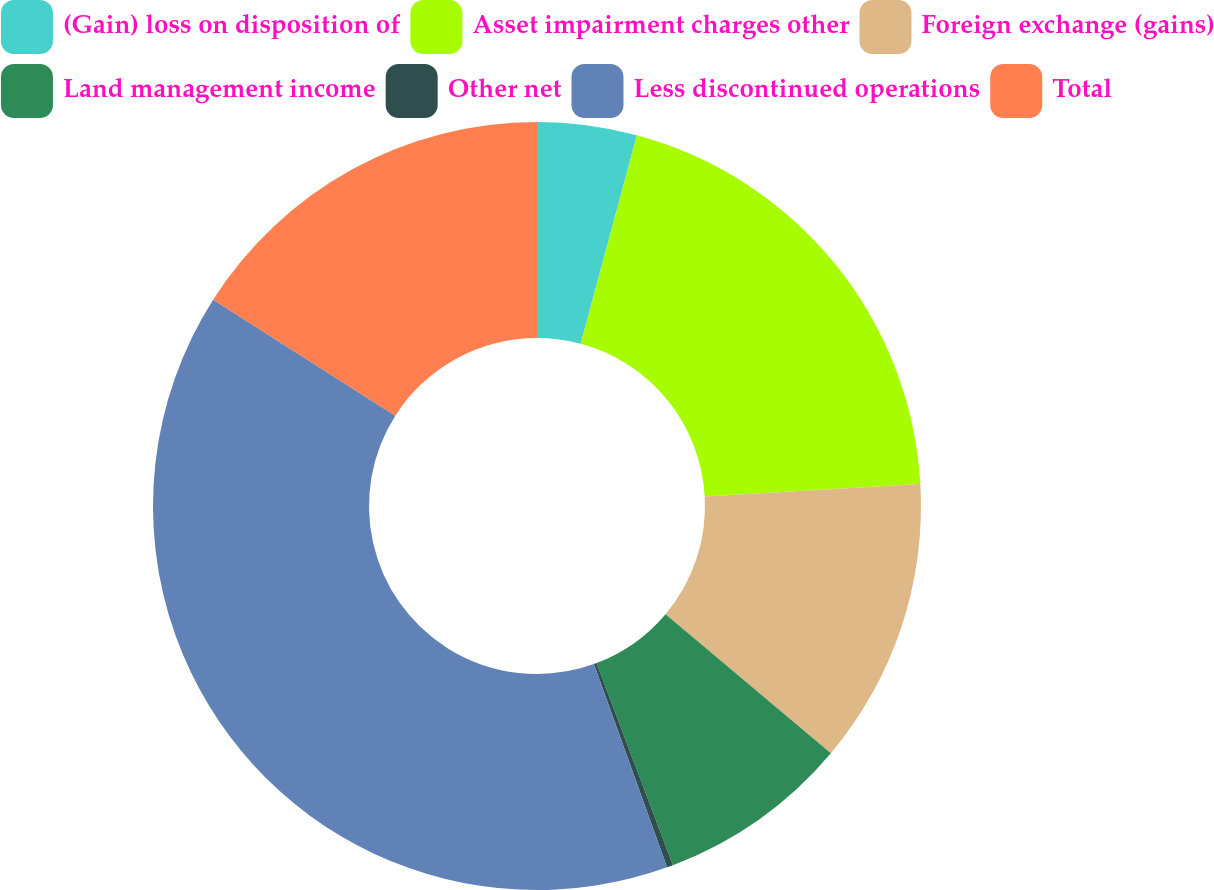Convert chart. <chart><loc_0><loc_0><loc_500><loc_500><pie_chart><fcel>(Gain) loss on disposition of<fcel>Asset impairment charges other<fcel>Foreign exchange (gains)<fcel>Land management income<fcel>Other net<fcel>Less discontinued operations<fcel>Total<nl><fcel>4.19%<fcel>19.9%<fcel>12.04%<fcel>8.11%<fcel>0.26%<fcel>39.53%<fcel>15.97%<nl></chart> 